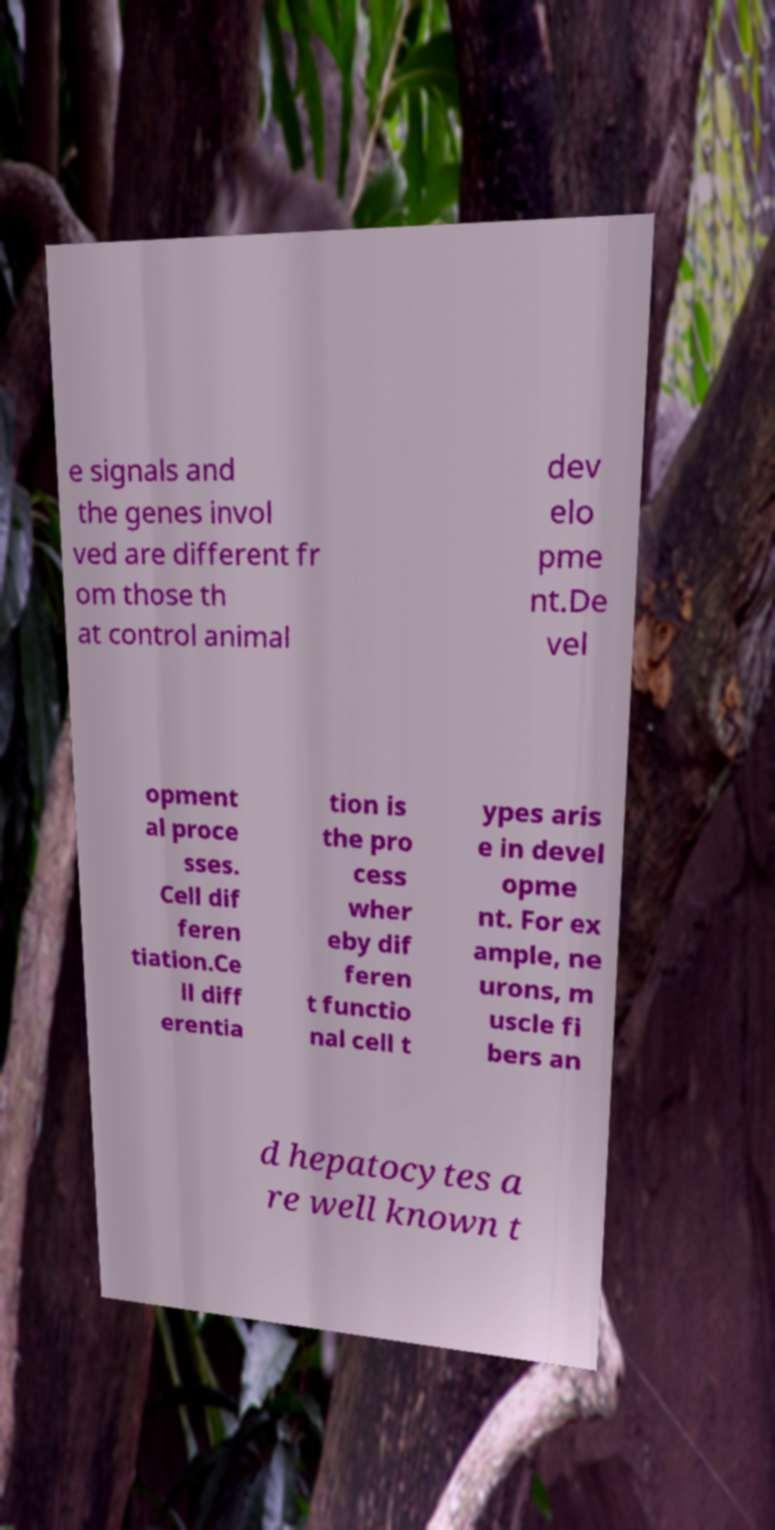Could you assist in decoding the text presented in this image and type it out clearly? e signals and the genes invol ved are different fr om those th at control animal dev elo pme nt.De vel opment al proce sses. Cell dif feren tiation.Ce ll diff erentia tion is the pro cess wher eby dif feren t functio nal cell t ypes aris e in devel opme nt. For ex ample, ne urons, m uscle fi bers an d hepatocytes a re well known t 